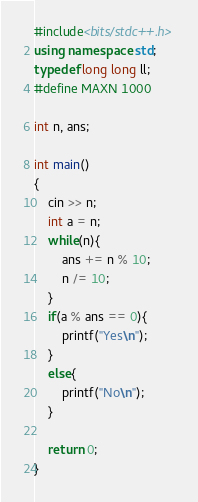Convert code to text. <code><loc_0><loc_0><loc_500><loc_500><_C++_>#include<bits/stdc++.h>
using namespace std;
typedef long long ll;
#define MAXN 1000

int n, ans;

int main()
{
    cin >> n;
    int a = n;
    while(n){
        ans += n % 10;
        n /= 10;
    }
    if(a % ans == 0){
        printf("Yes\n");
    }
    else{
        printf("No\n");
    }

    return 0;
}
</code> 